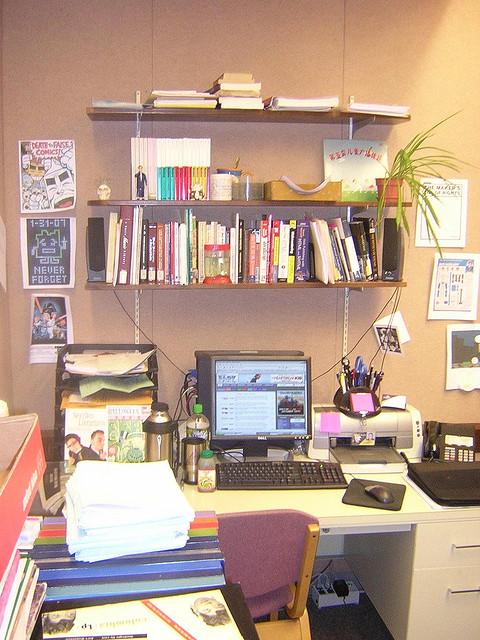Is the computer on?
Answer briefly. Yes. Is there a computer on the desk?
Short answer required. Yes. What color is the chair?
Short answer required. Pink. 